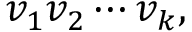Convert formula to latex. <formula><loc_0><loc_0><loc_500><loc_500>v _ { 1 } v _ { 2 } \cdots v _ { k } ,</formula> 